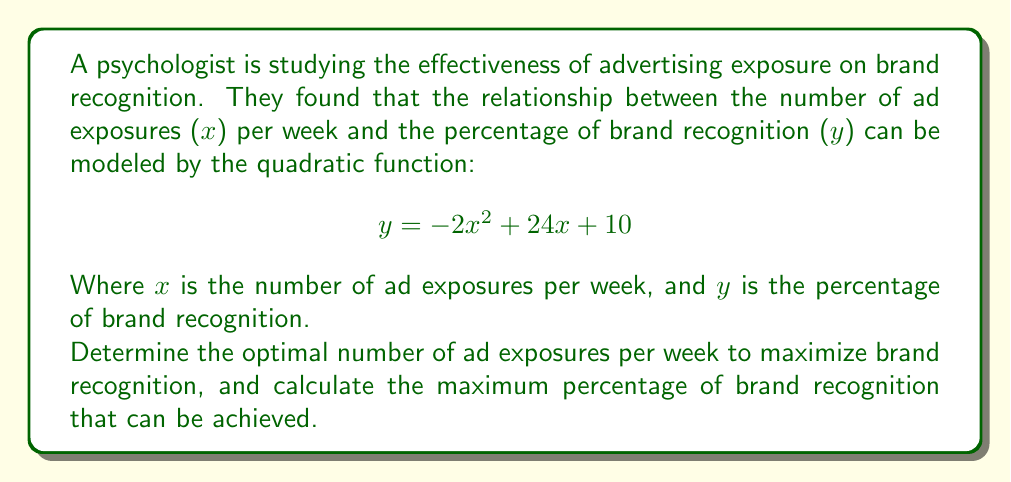What is the answer to this math problem? To solve this problem, we'll follow these steps:

1) The quadratic function given is in the form $y = ax^2 + bx + c$, where:
   $a = -2$, $b = 24$, and $c = 10$

2) For a quadratic function, the x-coordinate of the vertex represents the optimal x-value (in this case, the optimal number of ad exposures). We can find this using the formula:

   $$ x = -\frac{b}{2a} $$

3) Substituting our values:
   $$ x = -\frac{24}{2(-2)} = -\frac{24}{-4} = 6 $$

4) Therefore, the optimal number of ad exposures per week is 6.

5) To find the maximum percentage of brand recognition, we need to calculate the y-coordinate of the vertex. We can do this by substituting x = 6 into our original equation:

   $$ y = -2(6)^2 + 24(6) + 10 $$
   $$ y = -2(36) + 144 + 10 $$
   $$ y = -72 + 144 + 10 $$
   $$ y = 82 $$

6) Therefore, the maximum percentage of brand recognition that can be achieved is 82%.
Answer: 6 exposures per week; 82% maximum brand recognition 